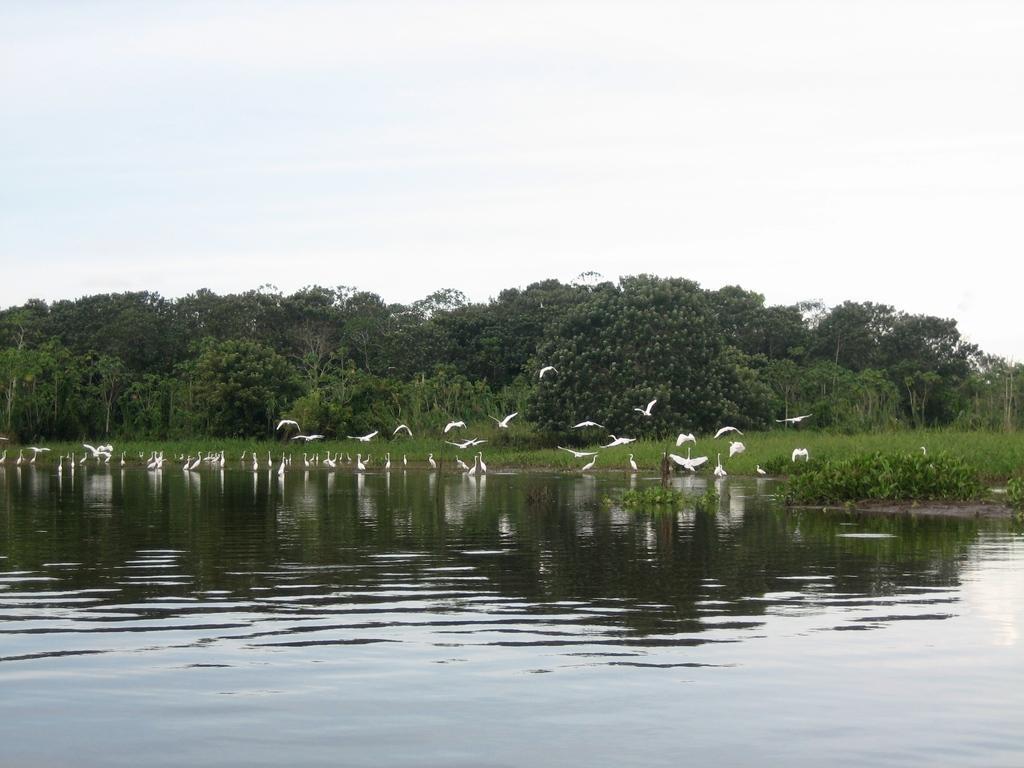Could you give a brief overview of what you see in this image? At the bottom of the image we can see a river and birds. In the background there are trees and sky. 